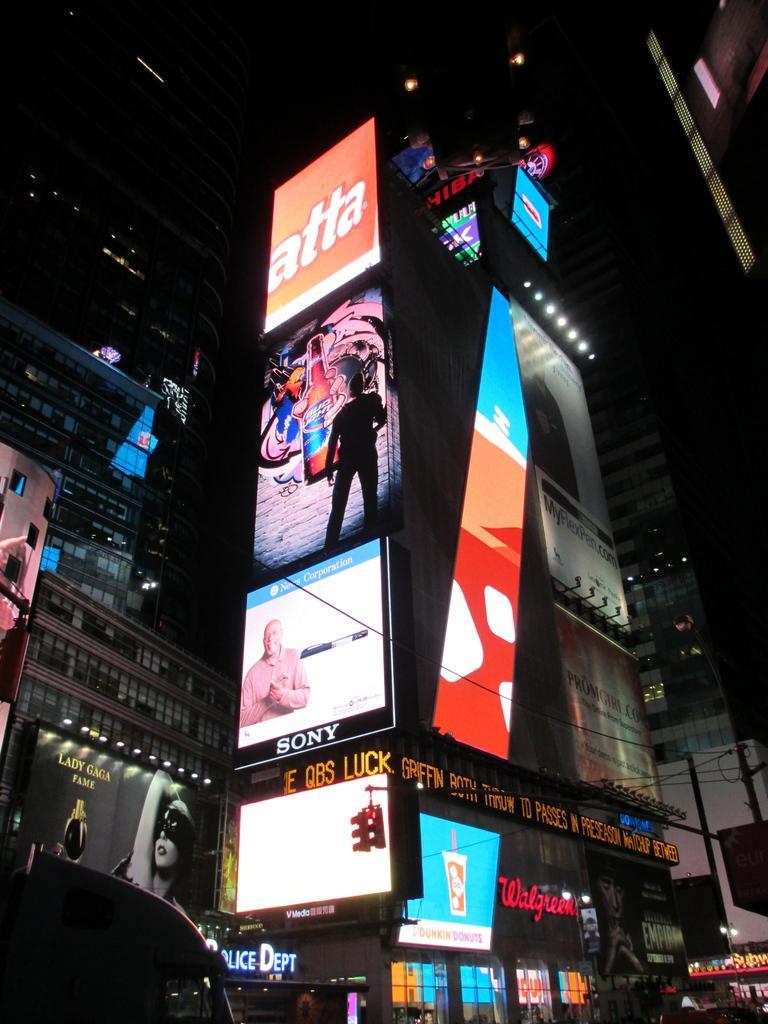Can you describe this image briefly? The picture consists of buildings, hoardings, lights and glass windows. In the foreground there is a car. At the top it is dark. 